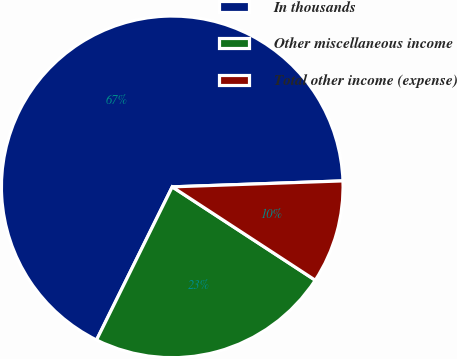Convert chart to OTSL. <chart><loc_0><loc_0><loc_500><loc_500><pie_chart><fcel>In thousands<fcel>Other miscellaneous income<fcel>Total other income (expense)<nl><fcel>67.13%<fcel>23.1%<fcel>9.76%<nl></chart> 